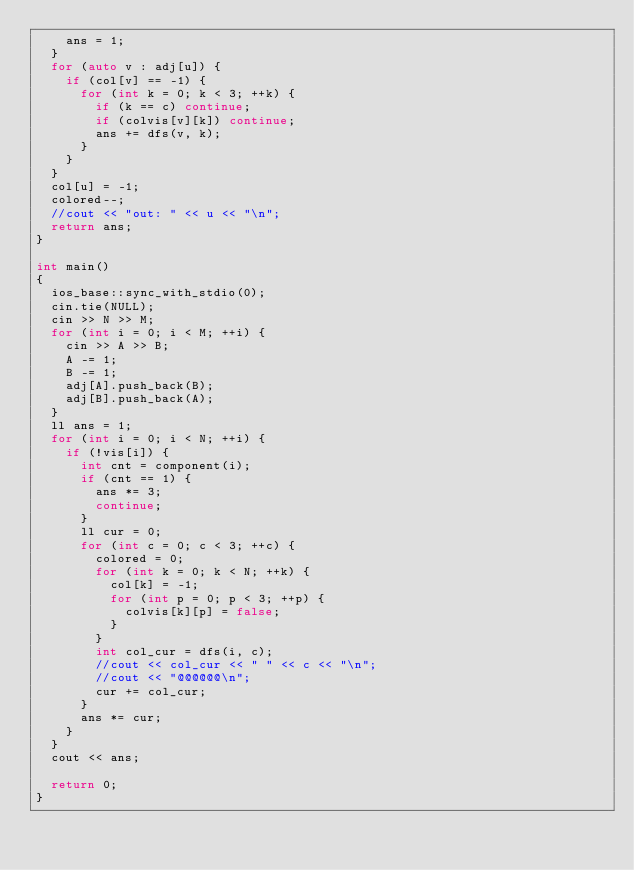<code> <loc_0><loc_0><loc_500><loc_500><_C++_>    ans = 1;
  }
  for (auto v : adj[u]) {
    if (col[v] == -1) {
      for (int k = 0; k < 3; ++k) {
        if (k == c) continue;
        if (colvis[v][k]) continue;
        ans += dfs(v, k);
      }
    }
  }
  col[u] = -1;
  colored--;
  //cout << "out: " << u << "\n";
  return ans;
}

int main()
{
  ios_base::sync_with_stdio(0);
  cin.tie(NULL);
  cin >> N >> M;
  for (int i = 0; i < M; ++i) {
    cin >> A >> B;
    A -= 1;
    B -= 1;
    adj[A].push_back(B);
    adj[B].push_back(A);
  }
  ll ans = 1;
  for (int i = 0; i < N; ++i) {
    if (!vis[i]) {
      int cnt = component(i);
      if (cnt == 1) {
        ans *= 3;
        continue;
      }
      ll cur = 0;
      for (int c = 0; c < 3; ++c) {
        colored = 0;
        for (int k = 0; k < N; ++k) {
          col[k] = -1;
          for (int p = 0; p < 3; ++p) {
            colvis[k][p] = false;
          }
        }
        int col_cur = dfs(i, c);
        //cout << col_cur << " " << c << "\n";
        //cout << "@@@@@@\n";
        cur += col_cur;
      }
      ans *= cur;
    }
  }
  cout << ans;

  return 0;
}
</code> 